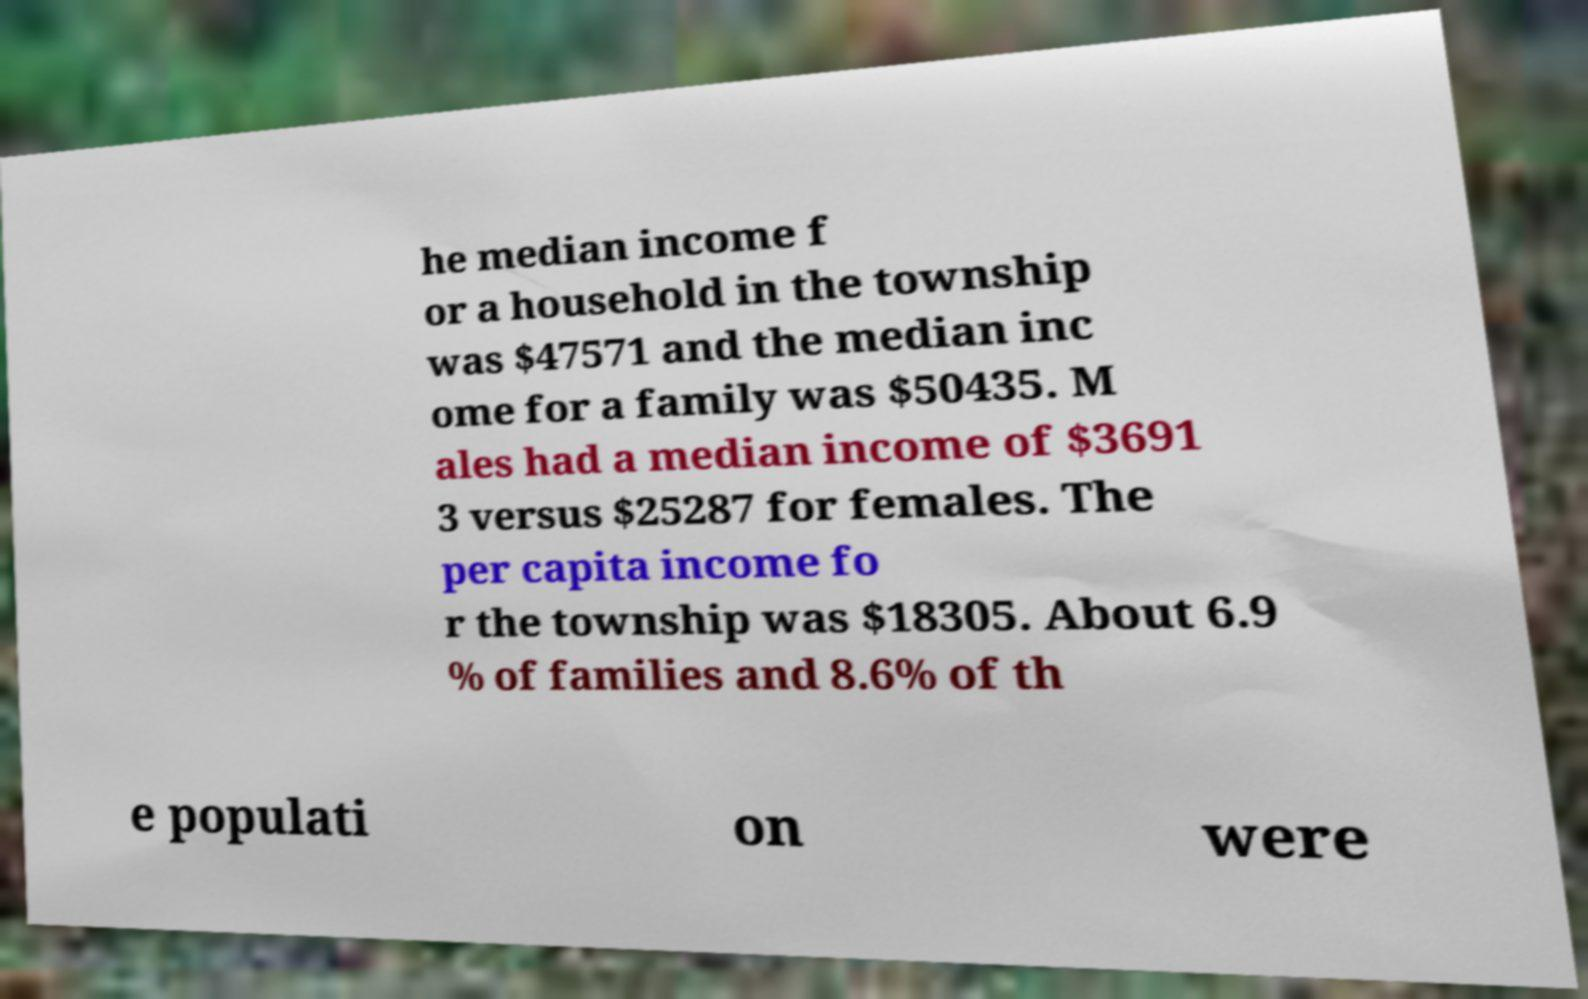There's text embedded in this image that I need extracted. Can you transcribe it verbatim? he median income f or a household in the township was $47571 and the median inc ome for a family was $50435. M ales had a median income of $3691 3 versus $25287 for females. The per capita income fo r the township was $18305. About 6.9 % of families and 8.6% of th e populati on were 